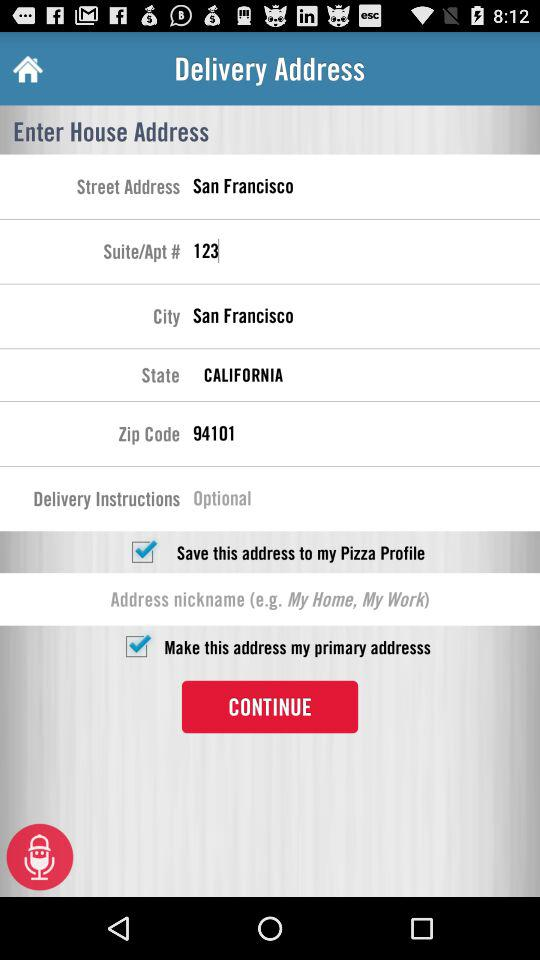What's the status of "Make this address my primary addresss"? The status of "Make this address my primary addresss" is "on". 